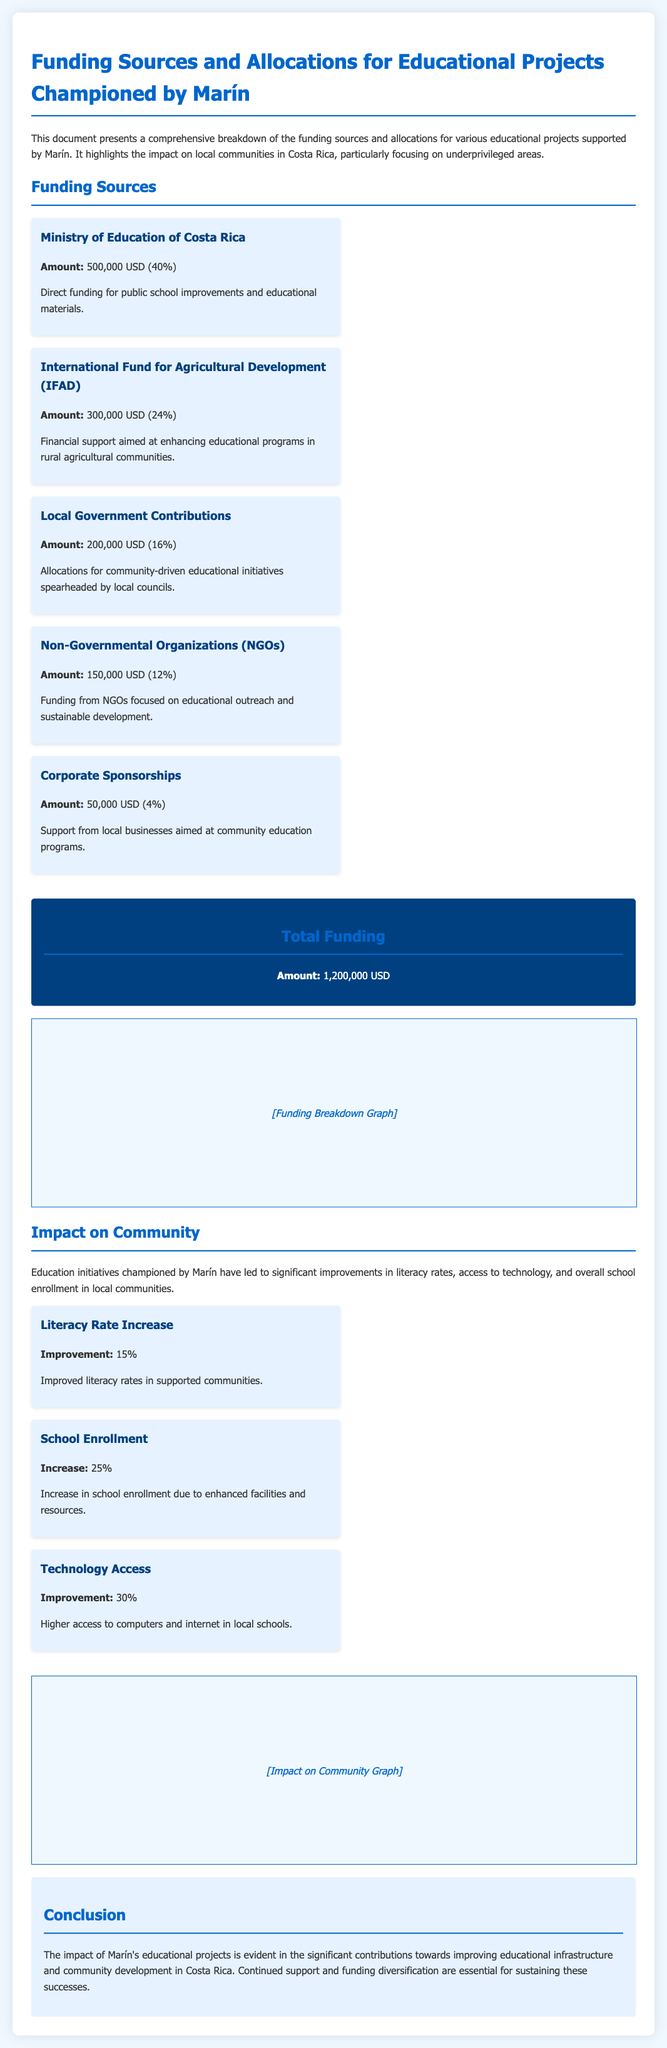What is the total funding amount? The total funding amount is prominently displayed in the document as 1,200,000 USD.
Answer: 1,200,000 USD Who provides the largest funding source? The largest funding source is identified as the Ministry of Education of Costa Rica, contributing 500,000 USD.
Answer: Ministry of Education of Costa Rica What percentage of total funding does Corporate Sponsorships represent? Corporate Sponsorships account for 4% of the total funding, according to the breakdown provided.
Answer: 4% What was the improvement in literacy rates due to Marín's projects? The document states that there was a 15% improvement in literacy rates in supported communities.
Answer: 15% How much funding does the International Fund for Agricultural Development (IFAD) provide? The amount provided by IFAD is specified as 300,000 USD in the funding sources section.
Answer: 300,000 USD Which impact metric shows the highest percentage increase? The highest percentage increase is in Technology Access, which improved by 30%.
Answer: 30% What type of community initiatives did Local Government Contributions fund? Local Government Contributions funded community-driven educational initiatives, as noted in the document.
Answer: Community-driven educational initiatives What is the conclusion drawn about Marín's educational projects? The conclusion highlights significant contributions towards improving educational infrastructure and community development.
Answer: Improving educational infrastructure and community development 